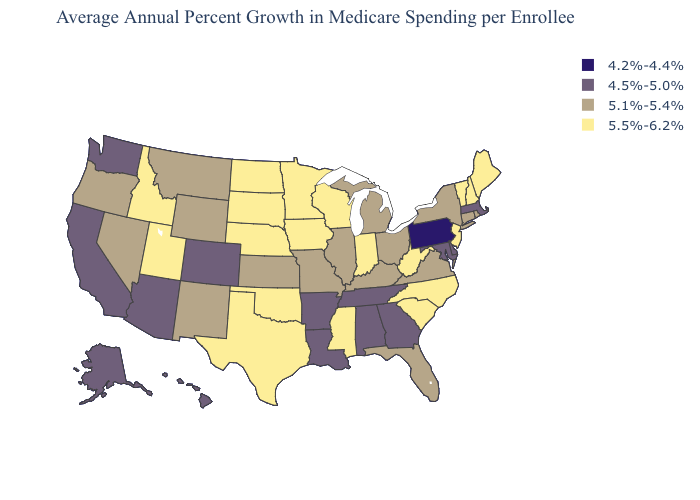What is the value of Illinois?
Keep it brief. 5.1%-5.4%. Name the states that have a value in the range 5.5%-6.2%?
Keep it brief. Idaho, Indiana, Iowa, Maine, Minnesota, Mississippi, Nebraska, New Hampshire, New Jersey, North Carolina, North Dakota, Oklahoma, South Carolina, South Dakota, Texas, Utah, Vermont, West Virginia, Wisconsin. Name the states that have a value in the range 4.5%-5.0%?
Keep it brief. Alabama, Alaska, Arizona, Arkansas, California, Colorado, Delaware, Georgia, Hawaii, Louisiana, Maryland, Massachusetts, Tennessee, Washington. What is the value of Delaware?
Concise answer only. 4.5%-5.0%. What is the lowest value in the MidWest?
Give a very brief answer. 5.1%-5.4%. Among the states that border Colorado , does Arizona have the lowest value?
Answer briefly. Yes. What is the value of Oregon?
Write a very short answer. 5.1%-5.4%. Does Pennsylvania have the lowest value in the USA?
Write a very short answer. Yes. Name the states that have a value in the range 5.1%-5.4%?
Concise answer only. Connecticut, Florida, Illinois, Kansas, Kentucky, Michigan, Missouri, Montana, Nevada, New Mexico, New York, Ohio, Oregon, Rhode Island, Virginia, Wyoming. Does Colorado have the same value as West Virginia?
Be succinct. No. What is the lowest value in the USA?
Short answer required. 4.2%-4.4%. Name the states that have a value in the range 5.5%-6.2%?
Give a very brief answer. Idaho, Indiana, Iowa, Maine, Minnesota, Mississippi, Nebraska, New Hampshire, New Jersey, North Carolina, North Dakota, Oklahoma, South Carolina, South Dakota, Texas, Utah, Vermont, West Virginia, Wisconsin. What is the lowest value in the South?
Concise answer only. 4.5%-5.0%. Does Connecticut have a higher value than Arkansas?
Be succinct. Yes. 